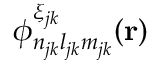<formula> <loc_0><loc_0><loc_500><loc_500>\phi _ { n _ { j k } l _ { j k } m _ { j k } } ^ { \xi _ { j k } } ( r )</formula> 